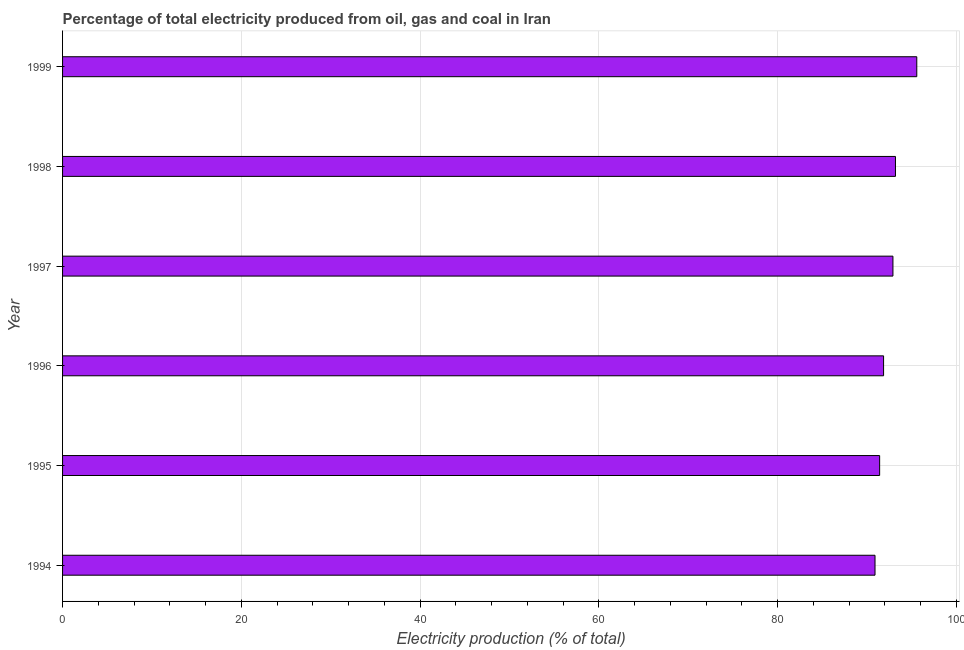Does the graph contain grids?
Your response must be concise. Yes. What is the title of the graph?
Offer a terse response. Percentage of total electricity produced from oil, gas and coal in Iran. What is the label or title of the X-axis?
Your response must be concise. Electricity production (% of total). What is the label or title of the Y-axis?
Provide a succinct answer. Year. What is the electricity production in 1996?
Offer a very short reply. 91.87. Across all years, what is the maximum electricity production?
Ensure brevity in your answer.  95.58. Across all years, what is the minimum electricity production?
Give a very brief answer. 90.91. What is the sum of the electricity production?
Keep it short and to the point. 555.88. What is the difference between the electricity production in 1996 and 1998?
Ensure brevity in your answer.  -1.33. What is the average electricity production per year?
Your response must be concise. 92.65. What is the median electricity production?
Keep it short and to the point. 92.39. In how many years, is the electricity production greater than 88 %?
Offer a terse response. 6. Is the electricity production in 1996 less than that in 1998?
Offer a very short reply. Yes. Is the difference between the electricity production in 1995 and 1998 greater than the difference between any two years?
Keep it short and to the point. No. What is the difference between the highest and the second highest electricity production?
Offer a very short reply. 2.38. Is the sum of the electricity production in 1995 and 1996 greater than the maximum electricity production across all years?
Your response must be concise. Yes. What is the difference between the highest and the lowest electricity production?
Provide a succinct answer. 4.67. What is the Electricity production (% of total) in 1994?
Your answer should be compact. 90.91. What is the Electricity production (% of total) of 1995?
Offer a very short reply. 91.42. What is the Electricity production (% of total) in 1996?
Your answer should be very brief. 91.87. What is the Electricity production (% of total) of 1997?
Give a very brief answer. 92.91. What is the Electricity production (% of total) of 1998?
Keep it short and to the point. 93.2. What is the Electricity production (% of total) of 1999?
Your response must be concise. 95.58. What is the difference between the Electricity production (% of total) in 1994 and 1995?
Keep it short and to the point. -0.52. What is the difference between the Electricity production (% of total) in 1994 and 1996?
Provide a short and direct response. -0.96. What is the difference between the Electricity production (% of total) in 1994 and 1997?
Your response must be concise. -2.01. What is the difference between the Electricity production (% of total) in 1994 and 1998?
Ensure brevity in your answer.  -2.29. What is the difference between the Electricity production (% of total) in 1994 and 1999?
Ensure brevity in your answer.  -4.67. What is the difference between the Electricity production (% of total) in 1995 and 1996?
Ensure brevity in your answer.  -0.44. What is the difference between the Electricity production (% of total) in 1995 and 1997?
Offer a terse response. -1.49. What is the difference between the Electricity production (% of total) in 1995 and 1998?
Make the answer very short. -1.77. What is the difference between the Electricity production (% of total) in 1995 and 1999?
Your answer should be very brief. -4.16. What is the difference between the Electricity production (% of total) in 1996 and 1997?
Ensure brevity in your answer.  -1.05. What is the difference between the Electricity production (% of total) in 1996 and 1998?
Ensure brevity in your answer.  -1.33. What is the difference between the Electricity production (% of total) in 1996 and 1999?
Give a very brief answer. -3.72. What is the difference between the Electricity production (% of total) in 1997 and 1998?
Give a very brief answer. -0.28. What is the difference between the Electricity production (% of total) in 1997 and 1999?
Offer a very short reply. -2.67. What is the difference between the Electricity production (% of total) in 1998 and 1999?
Your answer should be very brief. -2.38. What is the ratio of the Electricity production (% of total) in 1994 to that in 1995?
Offer a very short reply. 0.99. What is the ratio of the Electricity production (% of total) in 1994 to that in 1996?
Your response must be concise. 0.99. What is the ratio of the Electricity production (% of total) in 1994 to that in 1998?
Ensure brevity in your answer.  0.97. What is the ratio of the Electricity production (% of total) in 1994 to that in 1999?
Ensure brevity in your answer.  0.95. What is the ratio of the Electricity production (% of total) in 1995 to that in 1997?
Provide a succinct answer. 0.98. What is the ratio of the Electricity production (% of total) in 1995 to that in 1998?
Keep it short and to the point. 0.98. What is the ratio of the Electricity production (% of total) in 1995 to that in 1999?
Give a very brief answer. 0.96. What is the ratio of the Electricity production (% of total) in 1996 to that in 1998?
Ensure brevity in your answer.  0.99. What is the ratio of the Electricity production (% of total) in 1996 to that in 1999?
Your answer should be very brief. 0.96. What is the ratio of the Electricity production (% of total) in 1997 to that in 1999?
Make the answer very short. 0.97. What is the ratio of the Electricity production (% of total) in 1998 to that in 1999?
Provide a short and direct response. 0.97. 